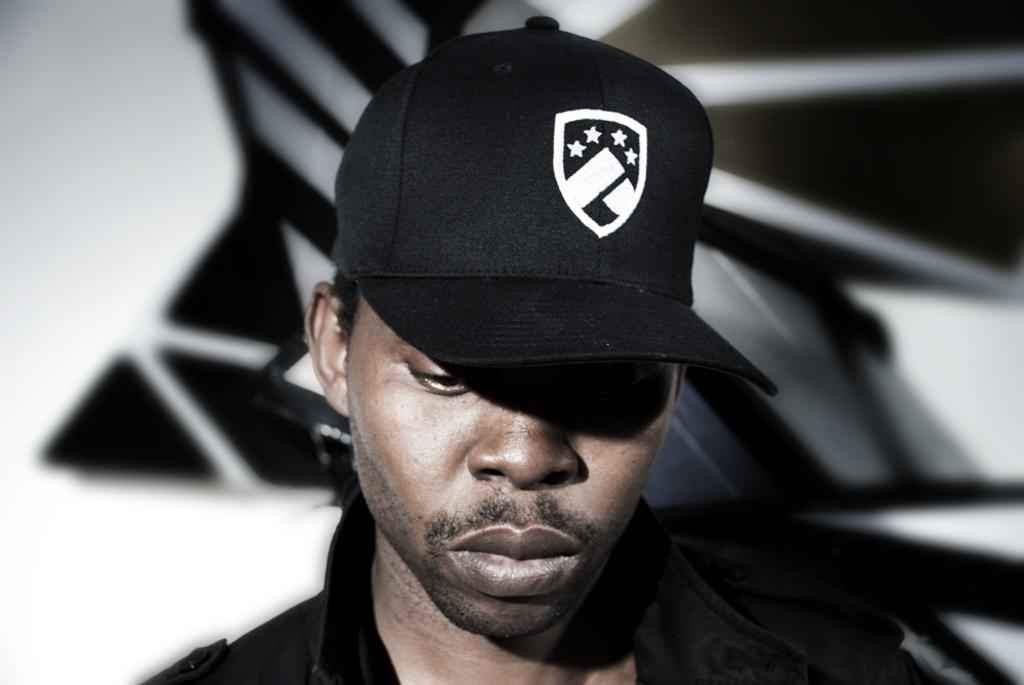Who is present in the image? There is a person in the image. What is the person wearing? The person is wearing a black dress and a black cap. What can be seen on the cap? There is a white logo on the cap. How would you describe the background of the image? The background of the image is blurred. Can you tell me how many brothers the person in the image has? There is no information about the person's family or siblings in the image, so it cannot be determined from the image. 